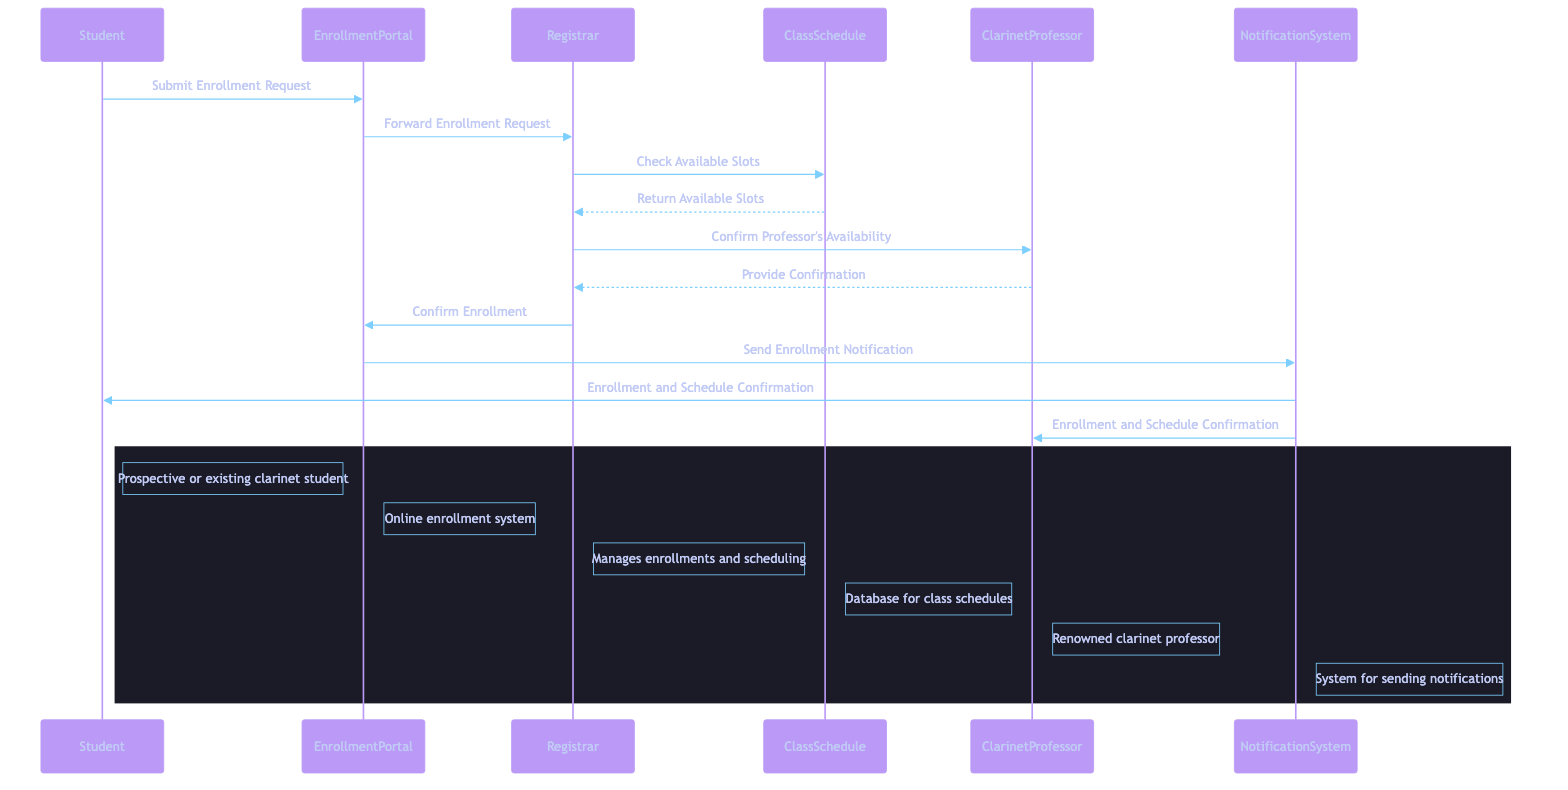What is the first action taken by the Student in the diagram? The first action is "Submit Enrollment Request," which is initiated by the Student towards the EnrollmentPortal. This is the starting point of the sequence as indicated by the first arrow in the diagram.
Answer: Submit Enrollment Request How many messages are exchanged in total? By counting each message represented by arrows in the diagram, there are 9 messages exchanged among the actors involved. This includes submissions, confirmations, and notifications.
Answer: 9 What system does the Student use to submit their enrollment? The Student uses the "EnrollmentPortal" to submit their enrollment request, as shown in the first interaction in the sequence diagram.
Answer: EnrollmentPortal Who does the Registrar communicate with to check class availability? The Registrar communicates with the "ClassSchedule" to check for available slots, as indicated by the arrow flowing from the Registrar to the ClassSchedule.
Answer: ClassSchedule What is the role of the NotificationSystem in the diagram? The NotificationSystem's role is to send enrollment and schedule confirmations to both the Student and the Clarinet Professor, as indicated by the final two arrows leading out from the NotificationSystem.
Answer: Send notifications What confirmation does the Registrar seek from the Clarinet Professor? The Registrar seeks to "Confirm Professor's Availability," which is a crucial step to ensure the professor can conduct the lessons at the requested time slots.
Answer: Confirm Professor's Availability After the student's enrollment is confirmed, what is the next step? After the enrollment is confirmed, the next step is for the EnrollmentPortal to "Send Enrollment Notification" to notify the relevant parties about the enrollment and schedule.
Answer: Send Enrollment Notification Which actor provides the confirmation about availability back to the Registrar? The actor providing the confirmation back to the Registrar is the "Clarinet Professor." This is represented as the flow returning to the Registrar from the Professor with the confirmation.
Answer: Clarinet Professor What action does the EnrollmentPortal undertake after the Registrar confirms enrollment? After the Registrar confirms the enrollment, the EnrollmentPortal undertakes the action to "Send Enrollment Notification" to both the Student and the Clarinet Professor, finalizing the process.
Answer: Send Enrollment Notification 